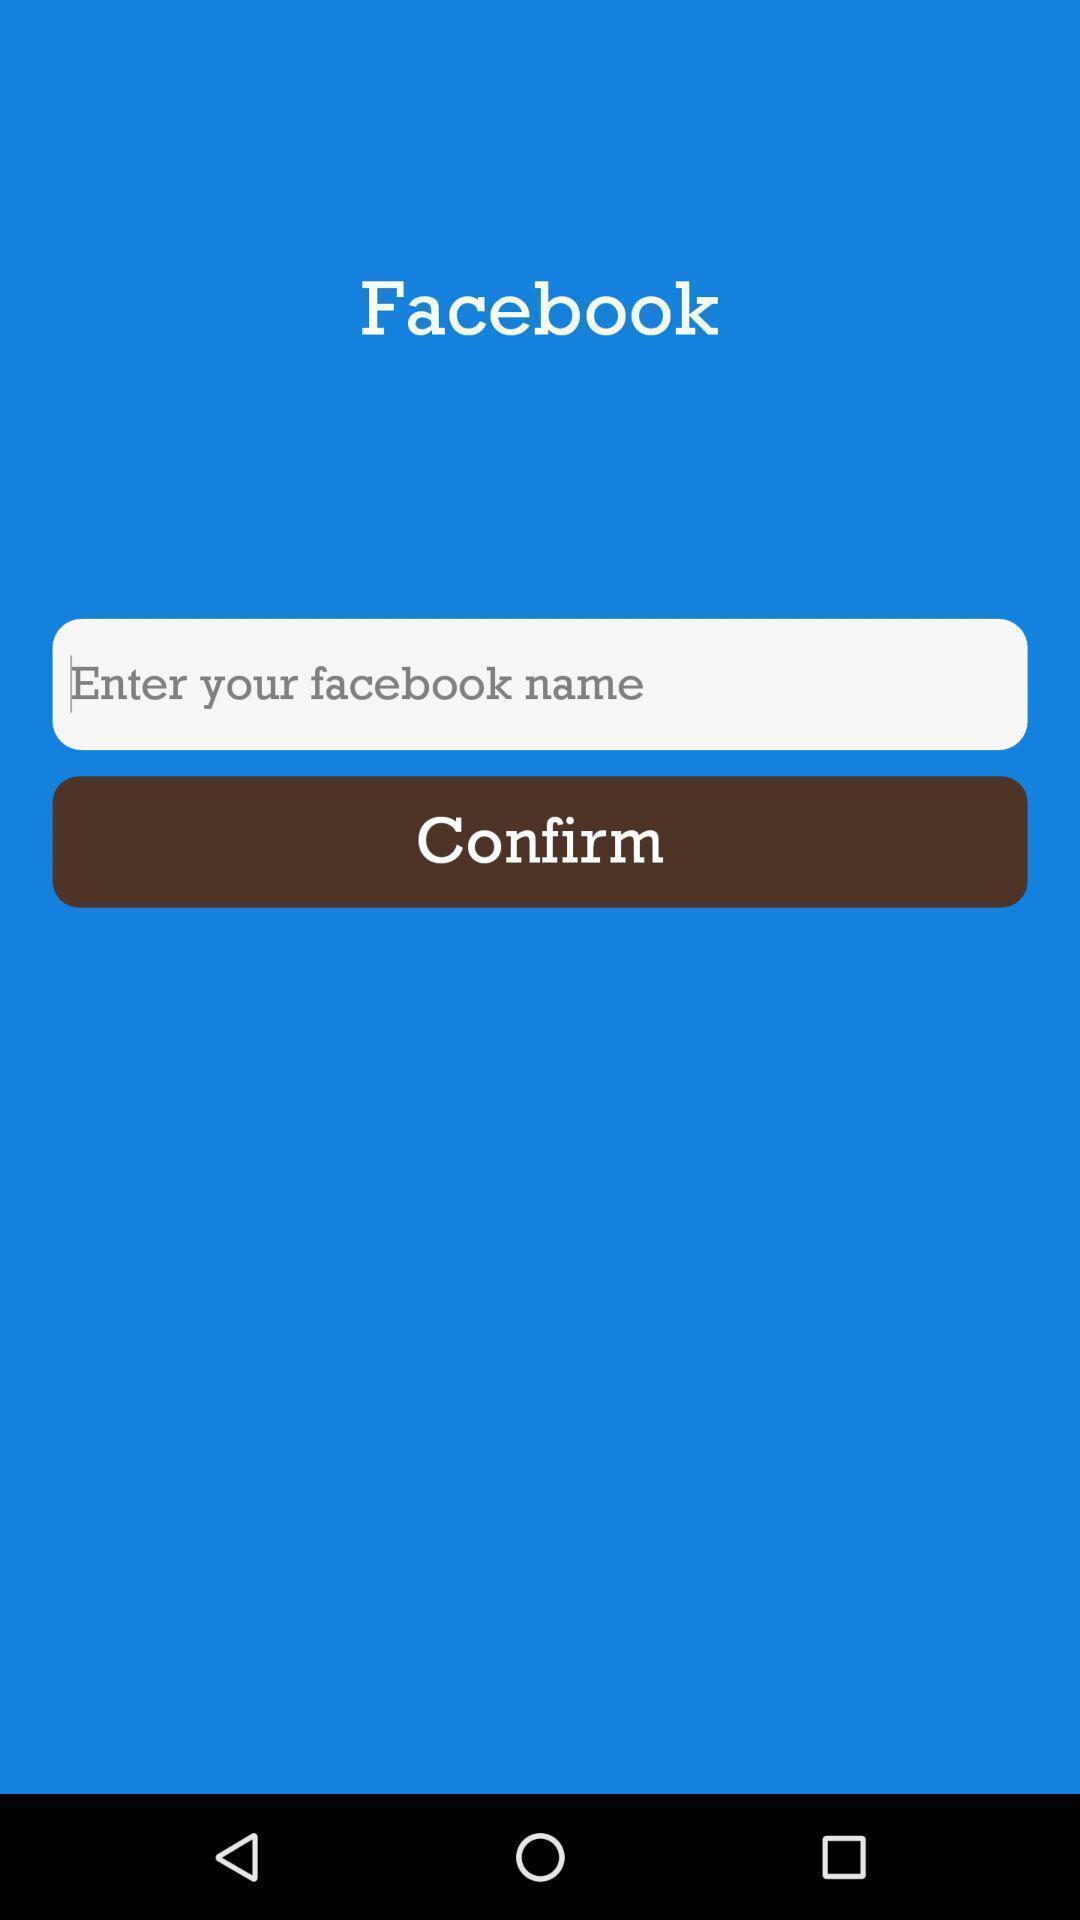What can you discern from this picture? Welcome page showing information to confirm. 